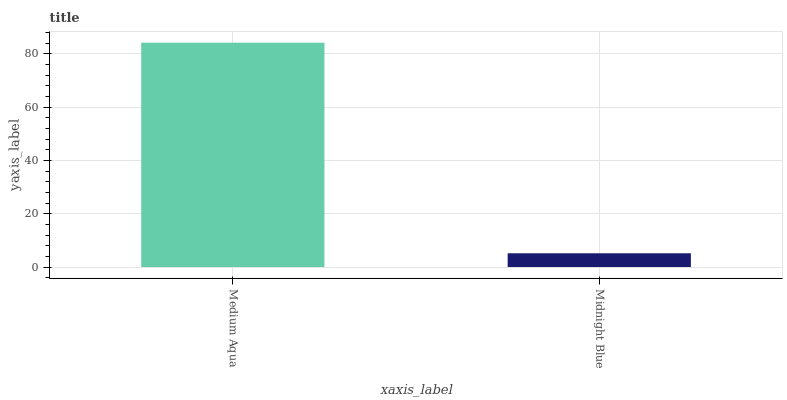Is Midnight Blue the minimum?
Answer yes or no. Yes. Is Medium Aqua the maximum?
Answer yes or no. Yes. Is Midnight Blue the maximum?
Answer yes or no. No. Is Medium Aqua greater than Midnight Blue?
Answer yes or no. Yes. Is Midnight Blue less than Medium Aqua?
Answer yes or no. Yes. Is Midnight Blue greater than Medium Aqua?
Answer yes or no. No. Is Medium Aqua less than Midnight Blue?
Answer yes or no. No. Is Medium Aqua the high median?
Answer yes or no. Yes. Is Midnight Blue the low median?
Answer yes or no. Yes. Is Midnight Blue the high median?
Answer yes or no. No. Is Medium Aqua the low median?
Answer yes or no. No. 